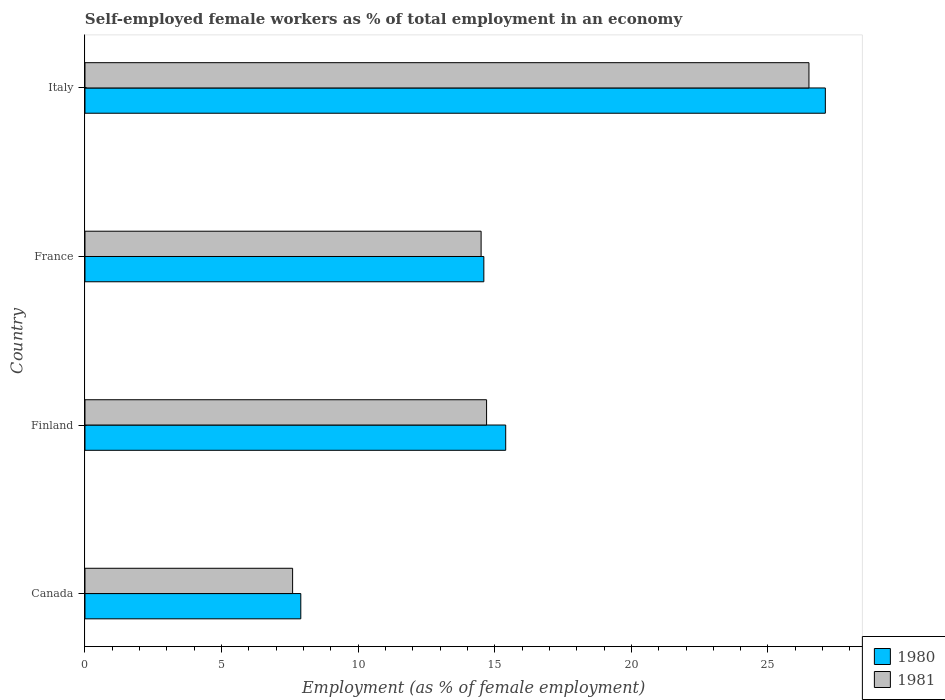How many different coloured bars are there?
Give a very brief answer. 2. How many bars are there on the 2nd tick from the top?
Give a very brief answer. 2. What is the percentage of self-employed female workers in 1981 in France?
Give a very brief answer. 14.5. Across all countries, what is the maximum percentage of self-employed female workers in 1981?
Give a very brief answer. 26.5. Across all countries, what is the minimum percentage of self-employed female workers in 1981?
Your answer should be very brief. 7.6. In which country was the percentage of self-employed female workers in 1980 maximum?
Provide a succinct answer. Italy. What is the total percentage of self-employed female workers in 1981 in the graph?
Give a very brief answer. 63.3. What is the difference between the percentage of self-employed female workers in 1980 in Finland and that in Italy?
Ensure brevity in your answer.  -11.7. What is the difference between the percentage of self-employed female workers in 1980 in Italy and the percentage of self-employed female workers in 1981 in France?
Give a very brief answer. 12.6. What is the average percentage of self-employed female workers in 1980 per country?
Your answer should be very brief. 16.25. What is the difference between the percentage of self-employed female workers in 1981 and percentage of self-employed female workers in 1980 in Finland?
Offer a very short reply. -0.7. In how many countries, is the percentage of self-employed female workers in 1980 greater than 22 %?
Provide a succinct answer. 1. What is the ratio of the percentage of self-employed female workers in 1981 in Canada to that in France?
Keep it short and to the point. 0.52. Is the difference between the percentage of self-employed female workers in 1981 in France and Italy greater than the difference between the percentage of self-employed female workers in 1980 in France and Italy?
Ensure brevity in your answer.  Yes. What is the difference between the highest and the second highest percentage of self-employed female workers in 1980?
Your answer should be very brief. 11.7. What is the difference between the highest and the lowest percentage of self-employed female workers in 1981?
Give a very brief answer. 18.9. Is the sum of the percentage of self-employed female workers in 1980 in Canada and France greater than the maximum percentage of self-employed female workers in 1981 across all countries?
Keep it short and to the point. No. What does the 2nd bar from the top in Canada represents?
Offer a terse response. 1980. What does the 1st bar from the bottom in Canada represents?
Give a very brief answer. 1980. How many bars are there?
Your response must be concise. 8. Are all the bars in the graph horizontal?
Provide a short and direct response. Yes. What is the difference between two consecutive major ticks on the X-axis?
Your answer should be compact. 5. Does the graph contain grids?
Your answer should be compact. No. Where does the legend appear in the graph?
Offer a very short reply. Bottom right. What is the title of the graph?
Keep it short and to the point. Self-employed female workers as % of total employment in an economy. Does "1976" appear as one of the legend labels in the graph?
Ensure brevity in your answer.  No. What is the label or title of the X-axis?
Your response must be concise. Employment (as % of female employment). What is the label or title of the Y-axis?
Your answer should be very brief. Country. What is the Employment (as % of female employment) in 1980 in Canada?
Your answer should be very brief. 7.9. What is the Employment (as % of female employment) of 1981 in Canada?
Provide a short and direct response. 7.6. What is the Employment (as % of female employment) of 1980 in Finland?
Make the answer very short. 15.4. What is the Employment (as % of female employment) in 1981 in Finland?
Offer a very short reply. 14.7. What is the Employment (as % of female employment) in 1980 in France?
Offer a terse response. 14.6. What is the Employment (as % of female employment) of 1981 in France?
Offer a very short reply. 14.5. What is the Employment (as % of female employment) in 1980 in Italy?
Offer a terse response. 27.1. What is the Employment (as % of female employment) in 1981 in Italy?
Give a very brief answer. 26.5. Across all countries, what is the maximum Employment (as % of female employment) in 1980?
Ensure brevity in your answer.  27.1. Across all countries, what is the maximum Employment (as % of female employment) of 1981?
Offer a terse response. 26.5. Across all countries, what is the minimum Employment (as % of female employment) of 1980?
Your answer should be compact. 7.9. Across all countries, what is the minimum Employment (as % of female employment) in 1981?
Make the answer very short. 7.6. What is the total Employment (as % of female employment) in 1980 in the graph?
Your answer should be compact. 65. What is the total Employment (as % of female employment) in 1981 in the graph?
Provide a short and direct response. 63.3. What is the difference between the Employment (as % of female employment) in 1981 in Canada and that in Finland?
Offer a terse response. -7.1. What is the difference between the Employment (as % of female employment) in 1980 in Canada and that in France?
Your answer should be compact. -6.7. What is the difference between the Employment (as % of female employment) in 1980 in Canada and that in Italy?
Ensure brevity in your answer.  -19.2. What is the difference between the Employment (as % of female employment) in 1981 in Canada and that in Italy?
Your response must be concise. -18.9. What is the difference between the Employment (as % of female employment) in 1980 in Finland and that in France?
Keep it short and to the point. 0.8. What is the difference between the Employment (as % of female employment) of 1980 in Finland and that in Italy?
Ensure brevity in your answer.  -11.7. What is the difference between the Employment (as % of female employment) of 1981 in Finland and that in Italy?
Your answer should be compact. -11.8. What is the difference between the Employment (as % of female employment) in 1980 in France and that in Italy?
Give a very brief answer. -12.5. What is the difference between the Employment (as % of female employment) of 1981 in France and that in Italy?
Offer a terse response. -12. What is the difference between the Employment (as % of female employment) in 1980 in Canada and the Employment (as % of female employment) in 1981 in France?
Make the answer very short. -6.6. What is the difference between the Employment (as % of female employment) of 1980 in Canada and the Employment (as % of female employment) of 1981 in Italy?
Your answer should be compact. -18.6. What is the difference between the Employment (as % of female employment) of 1980 in Finland and the Employment (as % of female employment) of 1981 in France?
Make the answer very short. 0.9. What is the average Employment (as % of female employment) of 1980 per country?
Provide a short and direct response. 16.25. What is the average Employment (as % of female employment) of 1981 per country?
Your response must be concise. 15.82. What is the difference between the Employment (as % of female employment) of 1980 and Employment (as % of female employment) of 1981 in Canada?
Ensure brevity in your answer.  0.3. What is the ratio of the Employment (as % of female employment) in 1980 in Canada to that in Finland?
Your response must be concise. 0.51. What is the ratio of the Employment (as % of female employment) in 1981 in Canada to that in Finland?
Your answer should be very brief. 0.52. What is the ratio of the Employment (as % of female employment) of 1980 in Canada to that in France?
Ensure brevity in your answer.  0.54. What is the ratio of the Employment (as % of female employment) in 1981 in Canada to that in France?
Provide a succinct answer. 0.52. What is the ratio of the Employment (as % of female employment) of 1980 in Canada to that in Italy?
Make the answer very short. 0.29. What is the ratio of the Employment (as % of female employment) of 1981 in Canada to that in Italy?
Your answer should be compact. 0.29. What is the ratio of the Employment (as % of female employment) in 1980 in Finland to that in France?
Offer a very short reply. 1.05. What is the ratio of the Employment (as % of female employment) of 1981 in Finland to that in France?
Your answer should be very brief. 1.01. What is the ratio of the Employment (as % of female employment) of 1980 in Finland to that in Italy?
Keep it short and to the point. 0.57. What is the ratio of the Employment (as % of female employment) in 1981 in Finland to that in Italy?
Provide a succinct answer. 0.55. What is the ratio of the Employment (as % of female employment) of 1980 in France to that in Italy?
Provide a succinct answer. 0.54. What is the ratio of the Employment (as % of female employment) in 1981 in France to that in Italy?
Your response must be concise. 0.55. 